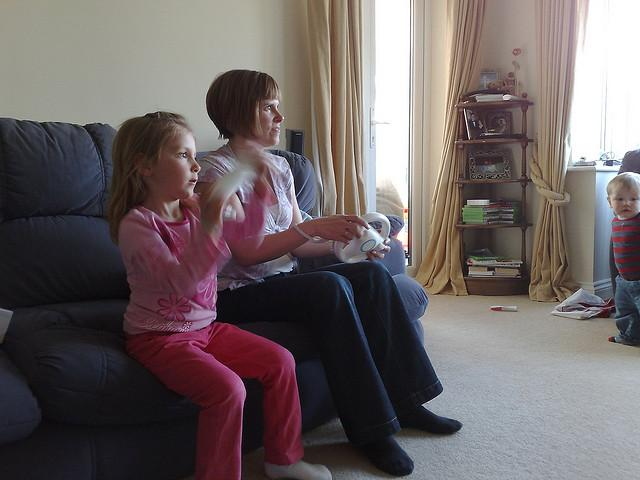What are the people on the couch looking at?

Choices:
A) mirror
B) child
C) picture window
D) gaming screen gaming screen 